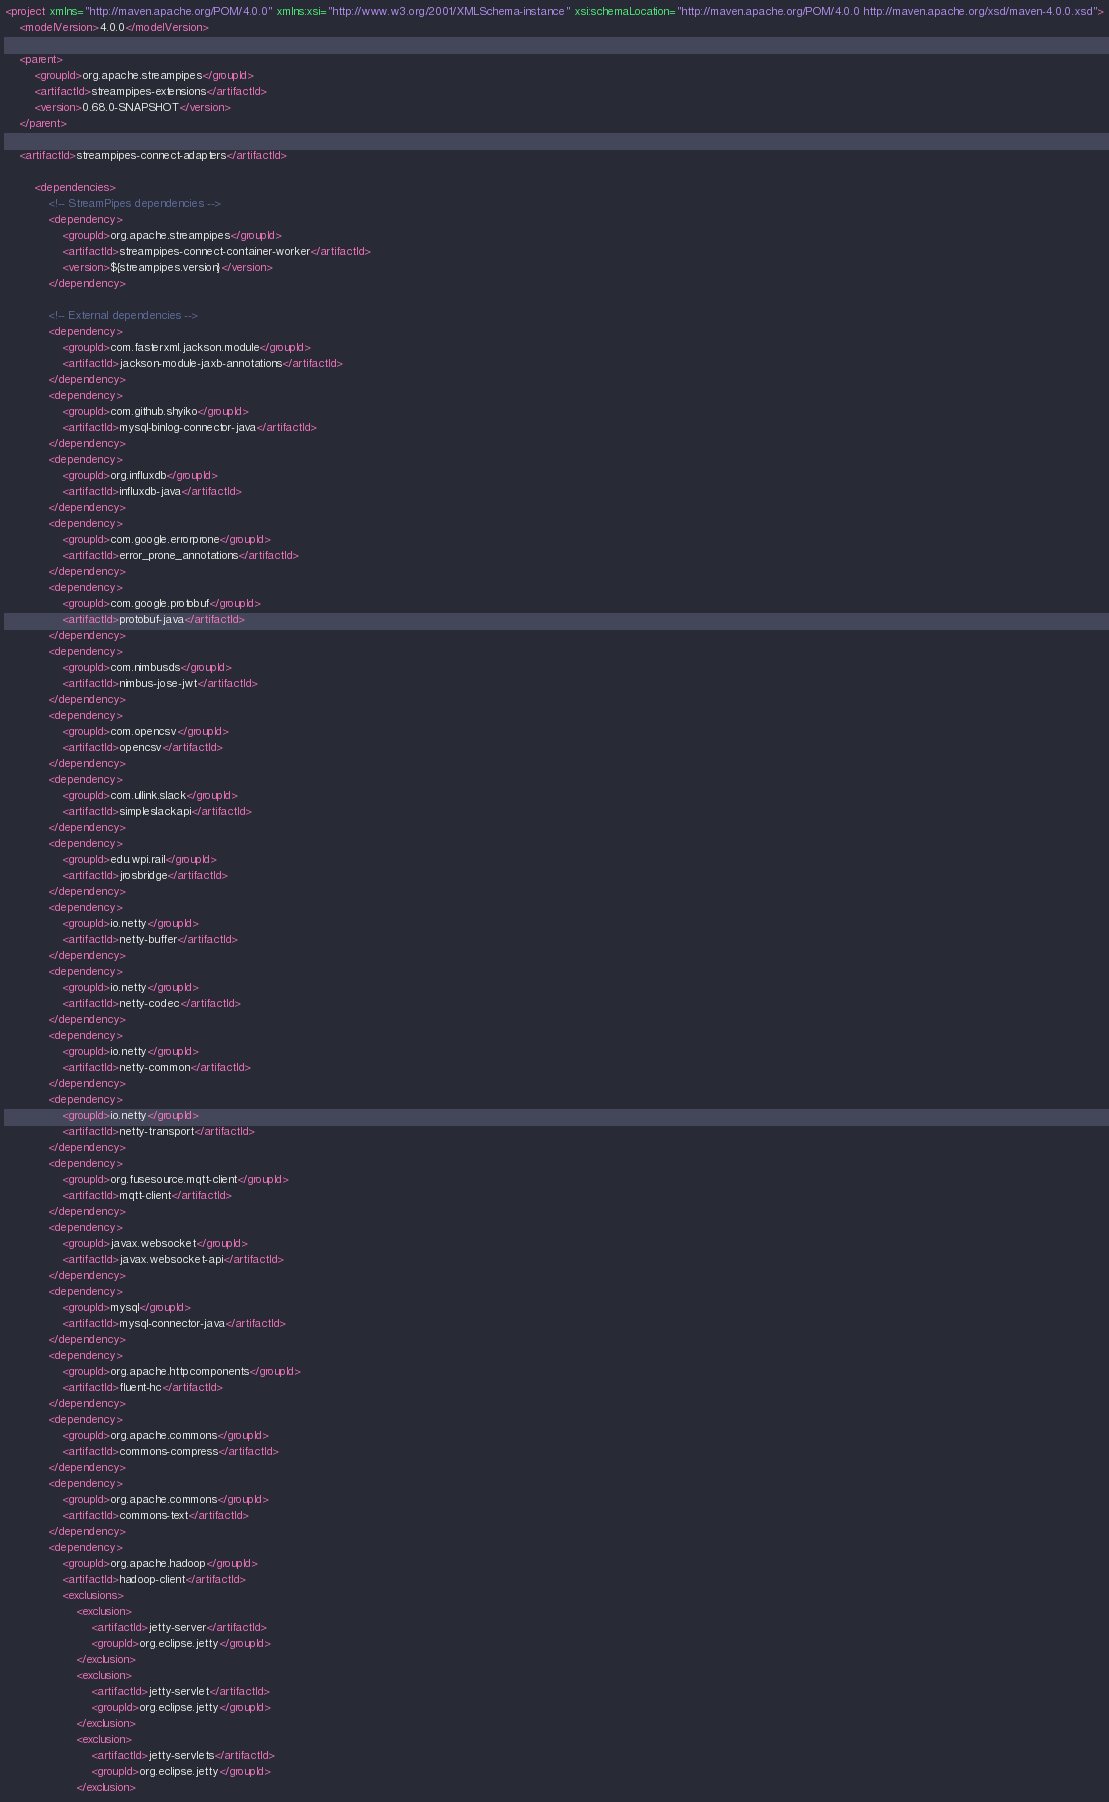<code> <loc_0><loc_0><loc_500><loc_500><_XML_>
<project xmlns="http://maven.apache.org/POM/4.0.0" xmlns:xsi="http://www.w3.org/2001/XMLSchema-instance" xsi:schemaLocation="http://maven.apache.org/POM/4.0.0 http://maven.apache.org/xsd/maven-4.0.0.xsd">
    <modelVersion>4.0.0</modelVersion>

    <parent>
        <groupId>org.apache.streampipes</groupId>
        <artifactId>streampipes-extensions</artifactId>
        <version>0.68.0-SNAPSHOT</version>
    </parent>

    <artifactId>streampipes-connect-adapters</artifactId>

        <dependencies>
            <!-- StreamPipes dependencies -->
            <dependency>
                <groupId>org.apache.streampipes</groupId>
                <artifactId>streampipes-connect-container-worker</artifactId>
                <version>${streampipes.version}</version>
            </dependency>

            <!-- External dependencies -->
            <dependency>
                <groupId>com.fasterxml.jackson.module</groupId>
                <artifactId>jackson-module-jaxb-annotations</artifactId>
            </dependency>
            <dependency>
                <groupId>com.github.shyiko</groupId>
                <artifactId>mysql-binlog-connector-java</artifactId>
            </dependency>
            <dependency>
                <groupId>org.influxdb</groupId>
                <artifactId>influxdb-java</artifactId>
            </dependency>
            <dependency>
                <groupId>com.google.errorprone</groupId>
                <artifactId>error_prone_annotations</artifactId>
            </dependency>
            <dependency>
                <groupId>com.google.protobuf</groupId>
                <artifactId>protobuf-java</artifactId>
            </dependency>
            <dependency>
                <groupId>com.nimbusds</groupId>
                <artifactId>nimbus-jose-jwt</artifactId>
            </dependency>
            <dependency>
                <groupId>com.opencsv</groupId>
                <artifactId>opencsv</artifactId>
            </dependency>
            <dependency>
                <groupId>com.ullink.slack</groupId>
                <artifactId>simpleslackapi</artifactId>
            </dependency>
            <dependency>
                <groupId>edu.wpi.rail</groupId>
                <artifactId>jrosbridge</artifactId>
            </dependency>
            <dependency>
                <groupId>io.netty</groupId>
                <artifactId>netty-buffer</artifactId>
            </dependency>
            <dependency>
                <groupId>io.netty</groupId>
                <artifactId>netty-codec</artifactId>
            </dependency>
            <dependency>
                <groupId>io.netty</groupId>
                <artifactId>netty-common</artifactId>
            </dependency>
            <dependency>
                <groupId>io.netty</groupId>
                <artifactId>netty-transport</artifactId>
            </dependency>
            <dependency>
                <groupId>org.fusesource.mqtt-client</groupId>
                <artifactId>mqtt-client</artifactId>
            </dependency>
            <dependency>
                <groupId>javax.websocket</groupId>
                <artifactId>javax.websocket-api</artifactId>
            </dependency>
            <dependency>
                <groupId>mysql</groupId>
                <artifactId>mysql-connector-java</artifactId>
            </dependency>
            <dependency>
                <groupId>org.apache.httpcomponents</groupId>
                <artifactId>fluent-hc</artifactId>
            </dependency>
            <dependency>
                <groupId>org.apache.commons</groupId>
                <artifactId>commons-compress</artifactId>
            </dependency>
            <dependency>
                <groupId>org.apache.commons</groupId>
                <artifactId>commons-text</artifactId>
            </dependency>
            <dependency>
                <groupId>org.apache.hadoop</groupId>
                <artifactId>hadoop-client</artifactId>
                <exclusions>
                    <exclusion>
                        <artifactId>jetty-server</artifactId>
                        <groupId>org.eclipse.jetty</groupId>
                    </exclusion>
                    <exclusion>
                        <artifactId>jetty-servlet</artifactId>
                        <groupId>org.eclipse.jetty</groupId>
                    </exclusion>
                    <exclusion>
                        <artifactId>jetty-servlets</artifactId>
                        <groupId>org.eclipse.jetty</groupId>
                    </exclusion></code> 